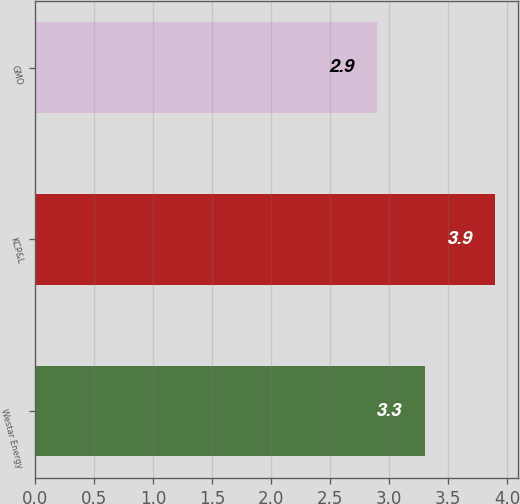Convert chart. <chart><loc_0><loc_0><loc_500><loc_500><bar_chart><fcel>Westar Energy<fcel>KCP&L<fcel>GMO<nl><fcel>3.3<fcel>3.9<fcel>2.9<nl></chart> 